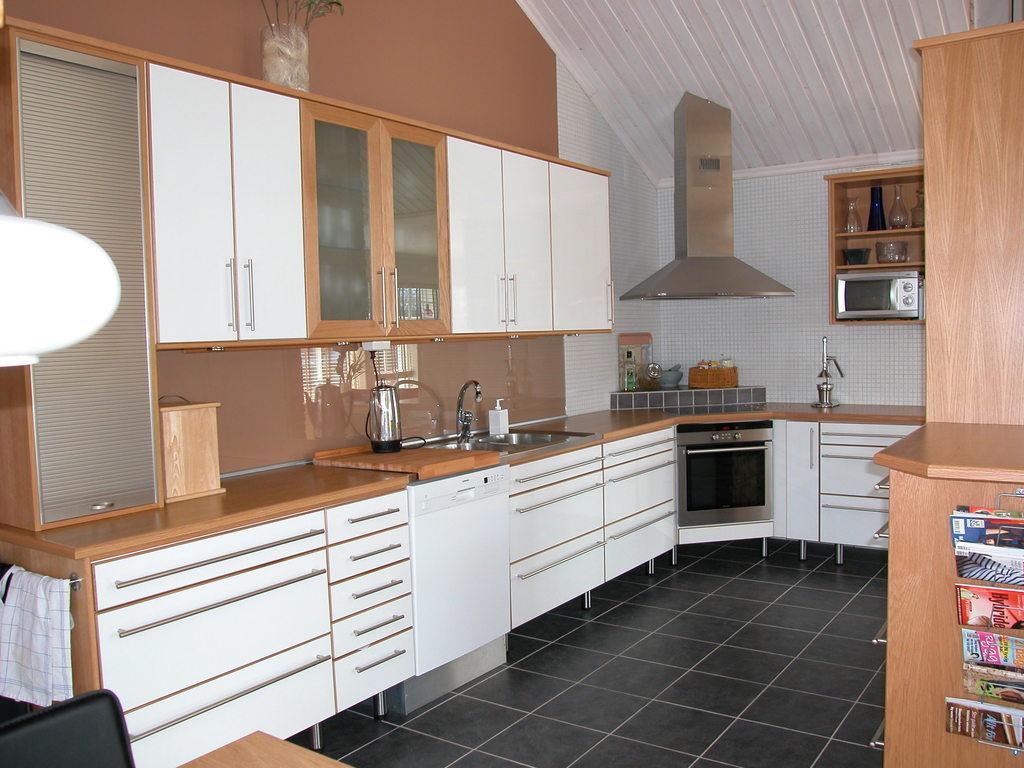Could you give a brief overview of what you see in this image? In this picture I can see wash basin and a bottle and I can see oven and few cupboards and I can see chimney and a microwave oven on the shelf and I can see few glass jars on the shelves and I can see napkins and few books. 